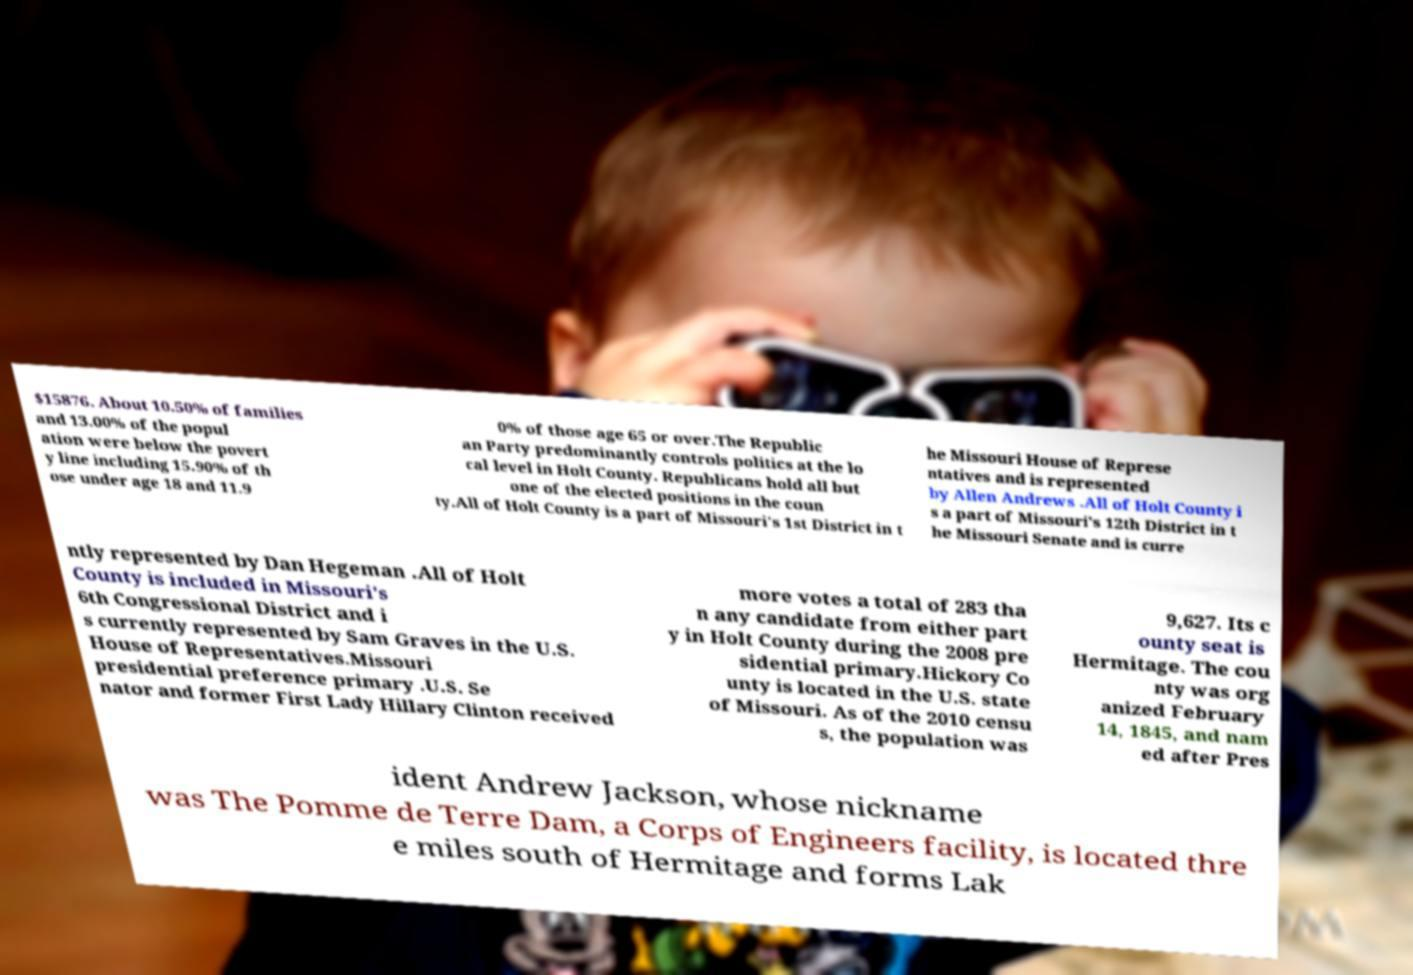Please identify and transcribe the text found in this image. $15876. About 10.50% of families and 13.00% of the popul ation were below the povert y line including 15.90% of th ose under age 18 and 11.9 0% of those age 65 or over.The Republic an Party predominantly controls politics at the lo cal level in Holt County. Republicans hold all but one of the elected positions in the coun ty.All of Holt County is a part of Missouri's 1st District in t he Missouri House of Represe ntatives and is represented by Allen Andrews .All of Holt County i s a part of Missouri's 12th District in t he Missouri Senate and is curre ntly represented by Dan Hegeman .All of Holt County is included in Missouri's 6th Congressional District and i s currently represented by Sam Graves in the U.S. House of Representatives.Missouri presidential preference primary .U.S. Se nator and former First Lady Hillary Clinton received more votes a total of 283 tha n any candidate from either part y in Holt County during the 2008 pre sidential primary.Hickory Co unty is located in the U.S. state of Missouri. As of the 2010 censu s, the population was 9,627. Its c ounty seat is Hermitage. The cou nty was org anized February 14, 1845, and nam ed after Pres ident Andrew Jackson, whose nickname was The Pomme de Terre Dam, a Corps of Engineers facility, is located thre e miles south of Hermitage and forms Lak 